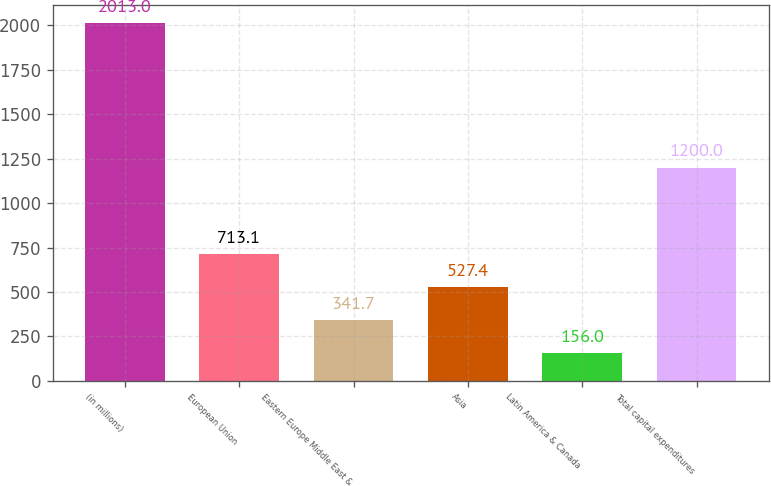Convert chart to OTSL. <chart><loc_0><loc_0><loc_500><loc_500><bar_chart><fcel>(in millions)<fcel>European Union<fcel>Eastern Europe Middle East &<fcel>Asia<fcel>Latin America & Canada<fcel>Total capital expenditures<nl><fcel>2013<fcel>713.1<fcel>341.7<fcel>527.4<fcel>156<fcel>1200<nl></chart> 